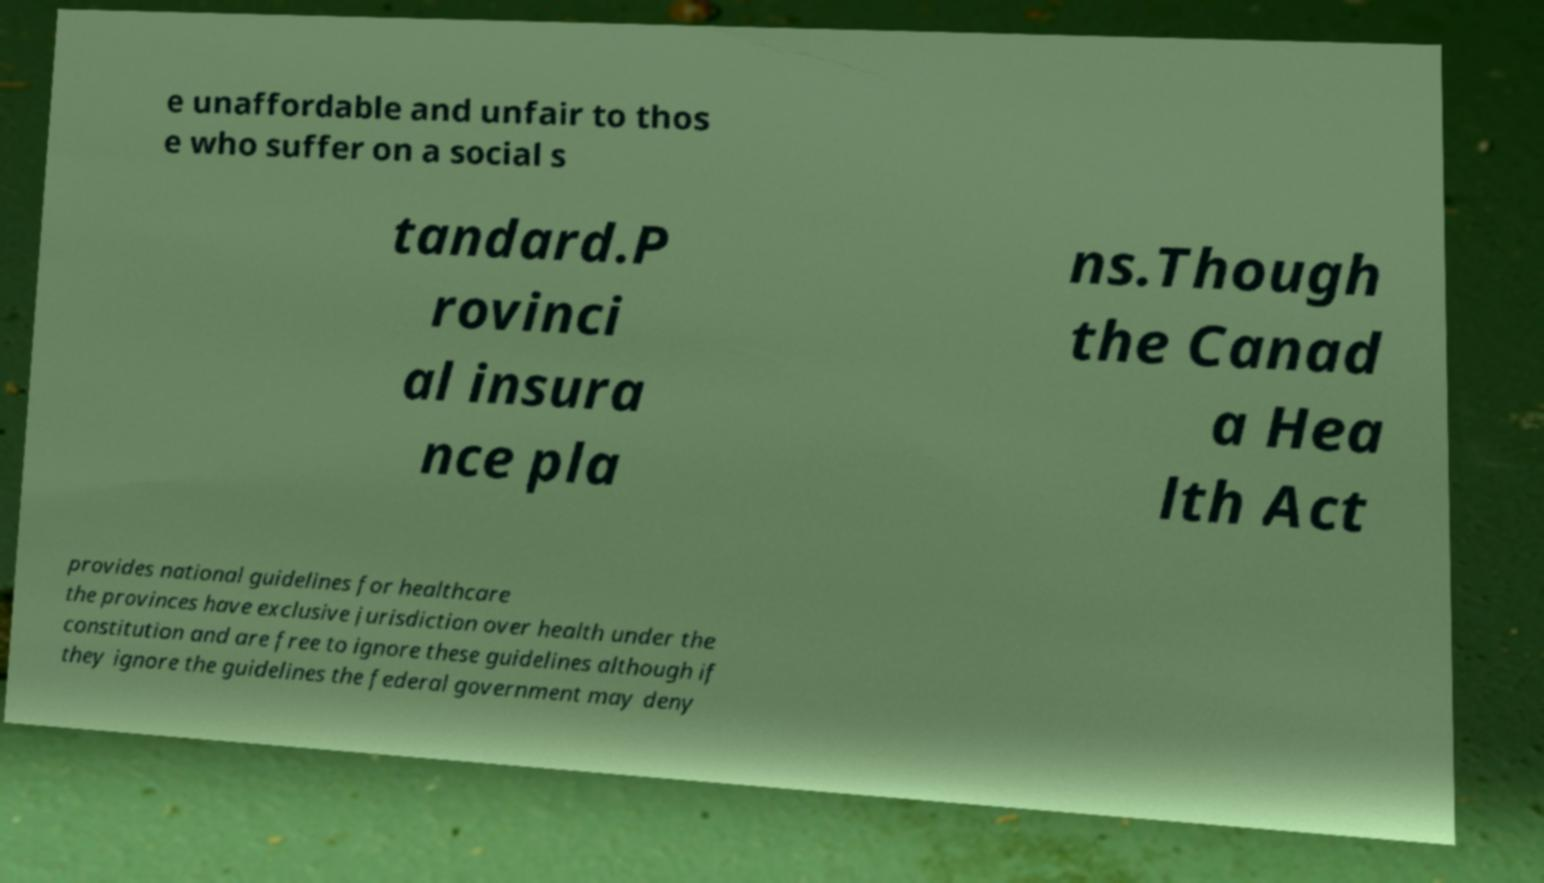There's text embedded in this image that I need extracted. Can you transcribe it verbatim? e unaffordable and unfair to thos e who suffer on a social s tandard.P rovinci al insura nce pla ns.Though the Canad a Hea lth Act provides national guidelines for healthcare the provinces have exclusive jurisdiction over health under the constitution and are free to ignore these guidelines although if they ignore the guidelines the federal government may deny 